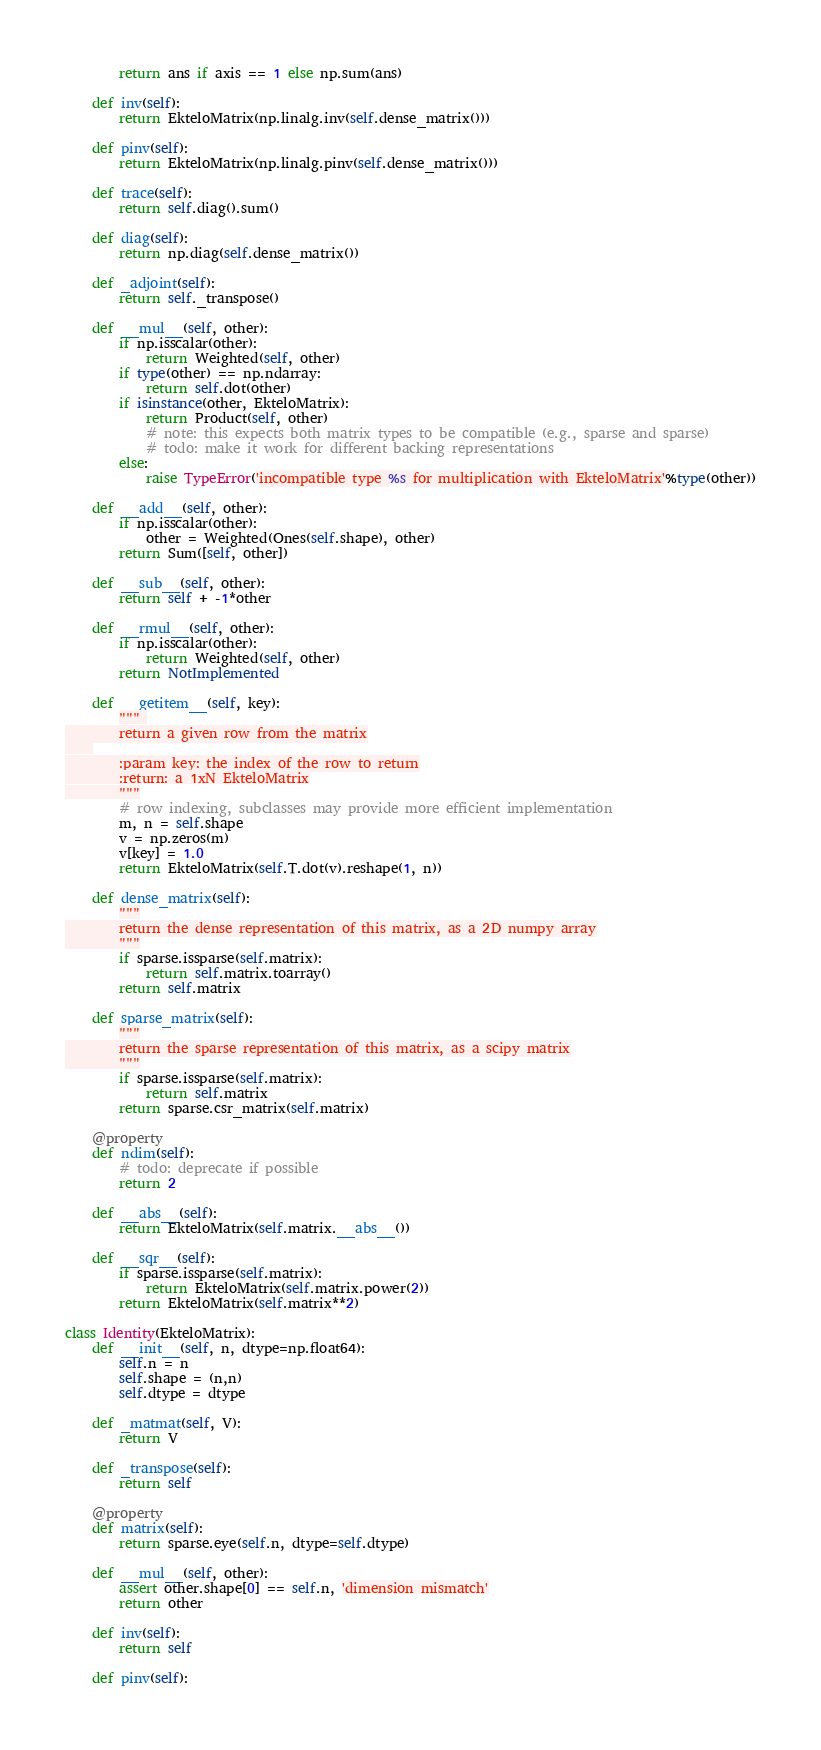<code> <loc_0><loc_0><loc_500><loc_500><_Python_>        return ans if axis == 1 else np.sum(ans)

    def inv(self):
        return EkteloMatrix(np.linalg.inv(self.dense_matrix()))

    def pinv(self):
        return EkteloMatrix(np.linalg.pinv(self.dense_matrix()))

    def trace(self):
        return self.diag().sum()

    def diag(self):
        return np.diag(self.dense_matrix())

    def _adjoint(self):
        return self._transpose()

    def __mul__(self, other):
        if np.isscalar(other):
            return Weighted(self, other)
        if type(other) == np.ndarray:
            return self.dot(other)
        if isinstance(other, EkteloMatrix):
            return Product(self, other)
            # note: this expects both matrix types to be compatible (e.g., sparse and sparse)
            # todo: make it work for different backing representations
        else:
            raise TypeError('incompatible type %s for multiplication with EkteloMatrix'%type(other))

    def __add__(self, other):
        if np.isscalar(other):
            other = Weighted(Ones(self.shape), other)
        return Sum([self, other])

    def __sub__(self, other):
        return self + -1*other
            
    def __rmul__(self, other):
        if np.isscalar(other):
            return Weighted(self, other)
        return NotImplemented

    def __getitem__(self, key):
        """ 
        return a given row from the matrix
    
        :param key: the index of the row to return
        :return: a 1xN EkteloMatrix
        """
        # row indexing, subclasses may provide more efficient implementation
        m, n = self.shape
        v = np.zeros(m)
        v[key] = 1.0
        return EkteloMatrix(self.T.dot(v).reshape(1, n))
    
    def dense_matrix(self):
        """
        return the dense representation of this matrix, as a 2D numpy array
        """
        if sparse.issparse(self.matrix):
            return self.matrix.toarray()
        return self.matrix
    
    def sparse_matrix(self):
        """
        return the sparse representation of this matrix, as a scipy matrix
        """
        if sparse.issparse(self.matrix):
            return self.matrix
        return sparse.csr_matrix(self.matrix)
    
    @property
    def ndim(self):
        # todo: deprecate if possible
        return 2
    
    def __abs__(self):
        return EkteloMatrix(self.matrix.__abs__())
    
    def __sqr__(self):
        if sparse.issparse(self.matrix):
            return EkteloMatrix(self.matrix.power(2))
        return EkteloMatrix(self.matrix**2)
   
class Identity(EkteloMatrix):
    def __init__(self, n, dtype=np.float64):
        self.n = n
        self.shape = (n,n)
        self.dtype = dtype
   
    def _matmat(self, V):
        return V
 
    def _transpose(self):
        return self

    @property
    def matrix(self):
        return sparse.eye(self.n, dtype=self.dtype)
    
    def __mul__(self, other):
        assert other.shape[0] == self.n, 'dimension mismatch'
        return other

    def inv(self):
        return self

    def pinv(self):</code> 